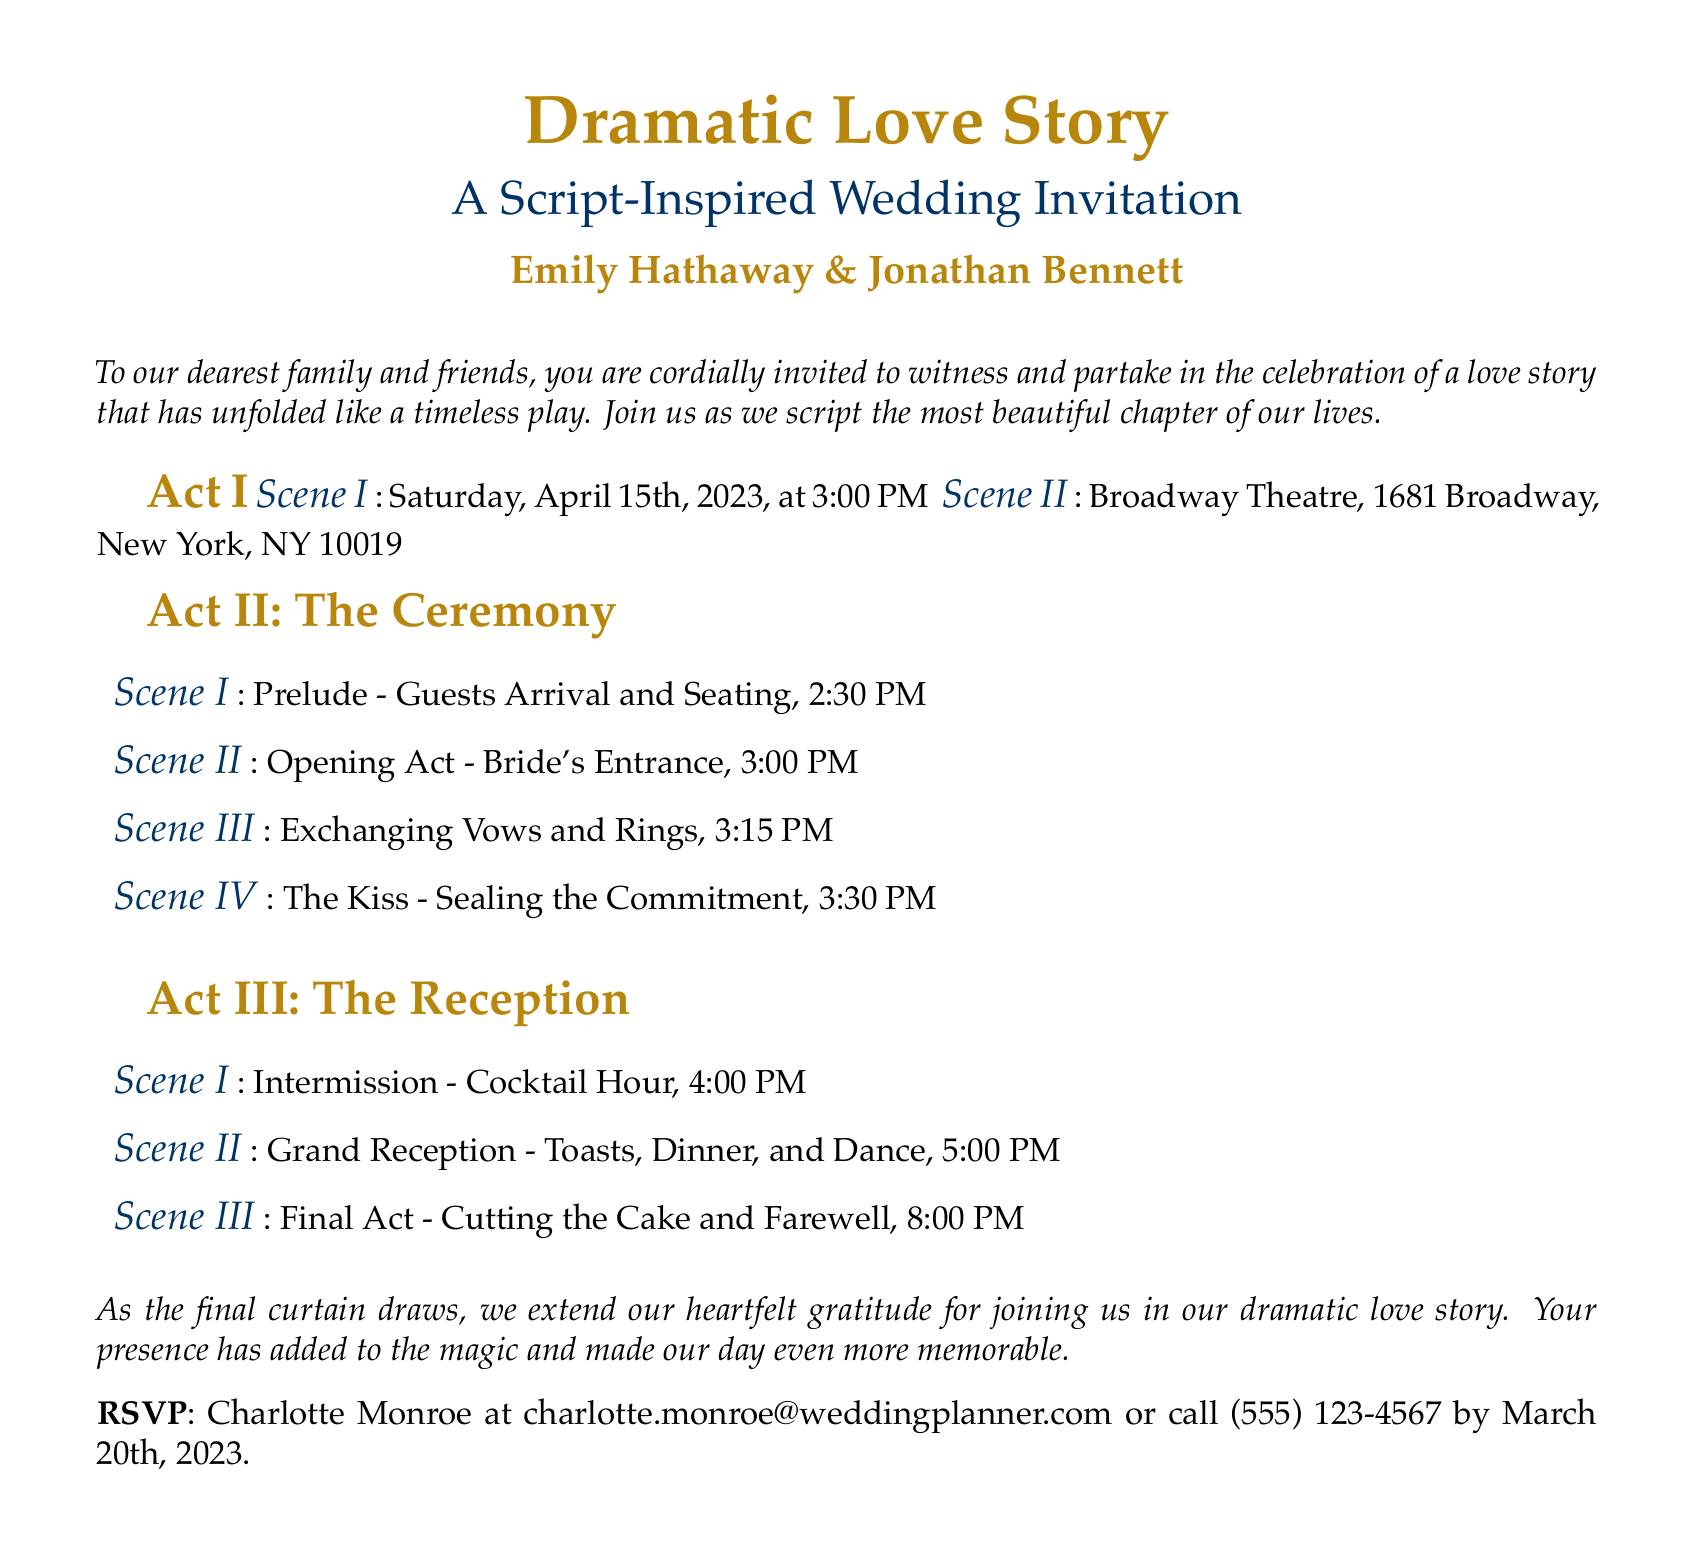What are the names of the couple? The names of the couple are located in the center of the invitation.
Answer: Emily Hathaway & Jonathan Bennett What is the date of the wedding? The date of the wedding is presented right after Act I.
Answer: April 15th, 2023 What time does the ceremony start? The start time of the ceremony is mentioned in Act II Scene II.
Answer: 3:00 PM What is the location of the wedding? The location of the wedding is provided in Act I Scene II.
Answer: Broadway Theatre, 1681 Broadway, New York, NY 10019 What is the RSVP deadline? The RSVP deadline is found toward the end of the invitation.
Answer: March 20th, 2023 How many acts are in the invitation? The total number of acts can be counted from the structure of the document.
Answer: Three What is included in the reception? The details of the reception are outlined in Act III.
Answer: Toasts, Dinner, and Dance What does the couple ask for at the end of the invitation? The couple expresses their gratitude toward the guests at the end.
Answer: Heartfelt gratitude What role does the reception play in the overall event? The reception serves as the final celebration of the wedding day.
Answer: Closing celebration 